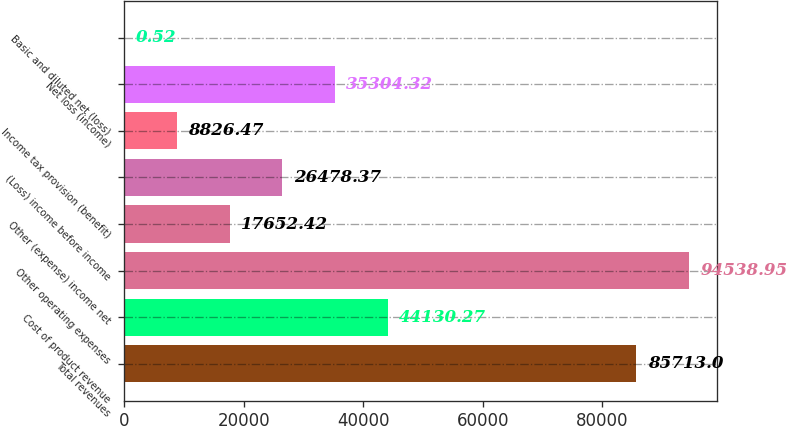<chart> <loc_0><loc_0><loc_500><loc_500><bar_chart><fcel>Total revenues<fcel>Cost of product revenue<fcel>Other operating expenses<fcel>Other (expense) income net<fcel>(Loss) income before income<fcel>Income tax provision (benefit)<fcel>Net loss (income)<fcel>Basic and diluted net (loss)<nl><fcel>85713<fcel>44130.3<fcel>94538.9<fcel>17652.4<fcel>26478.4<fcel>8826.47<fcel>35304.3<fcel>0.52<nl></chart> 